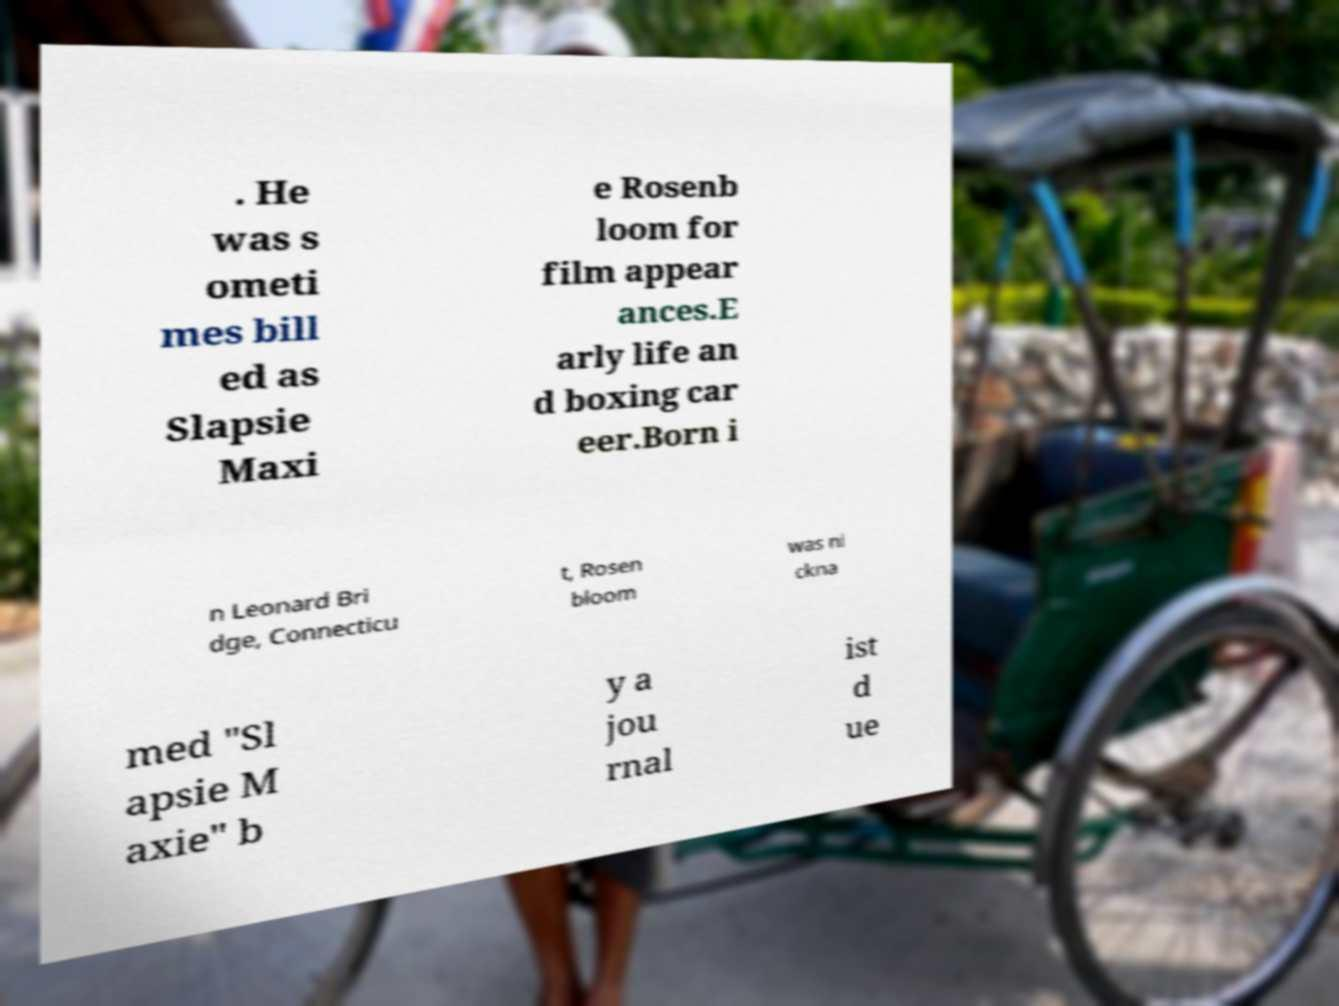Could you assist in decoding the text presented in this image and type it out clearly? . He was s ometi mes bill ed as Slapsie Maxi e Rosenb loom for film appear ances.E arly life an d boxing car eer.Born i n Leonard Bri dge, Connecticu t, Rosen bloom was ni ckna med "Sl apsie M axie" b y a jou rnal ist d ue 